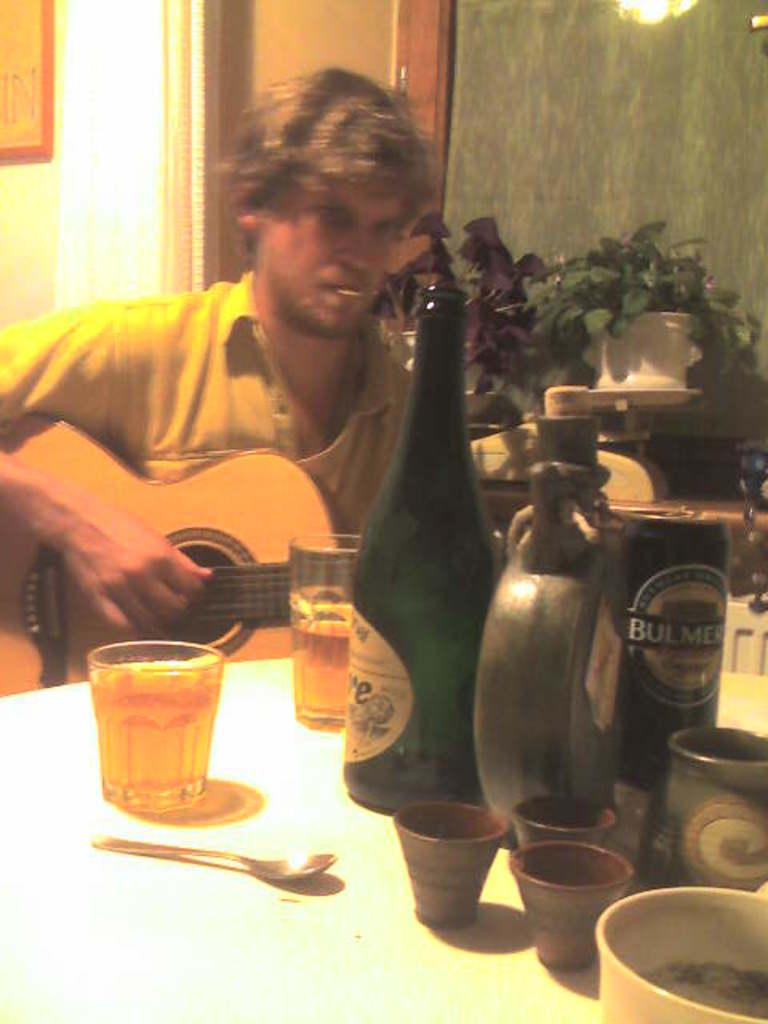<image>
Summarize the visual content of the image. A man plays guitar behind a table with a can of Bulmers. 